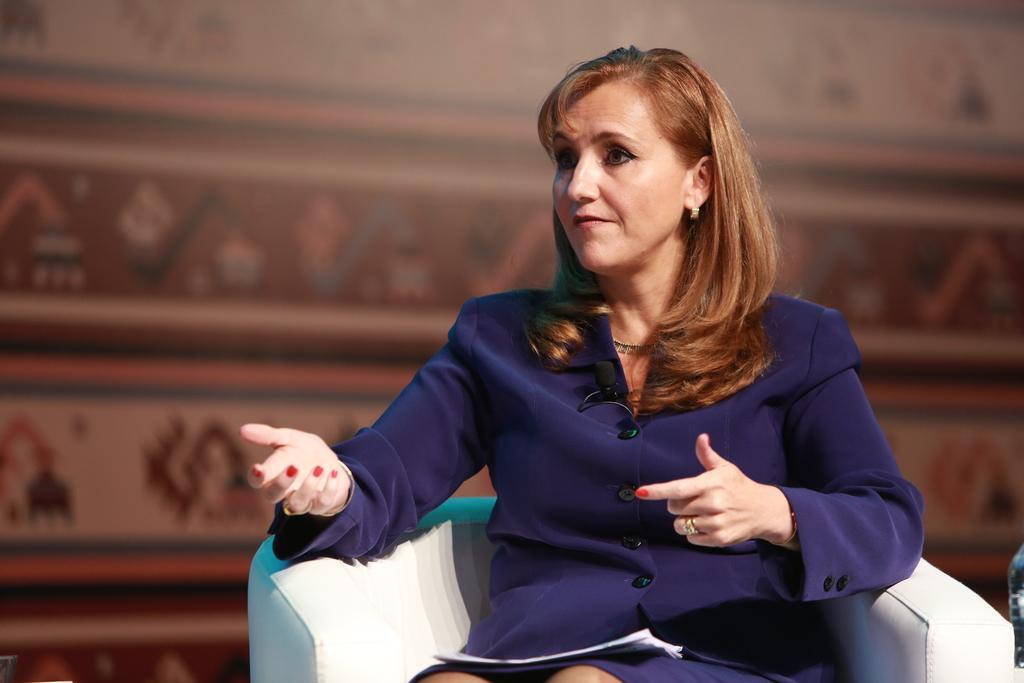Describe this image in one or two sentences. In the picture I can see a woman is sitting on a chair. The woman is holding some papers. The background of the image is blurred. 